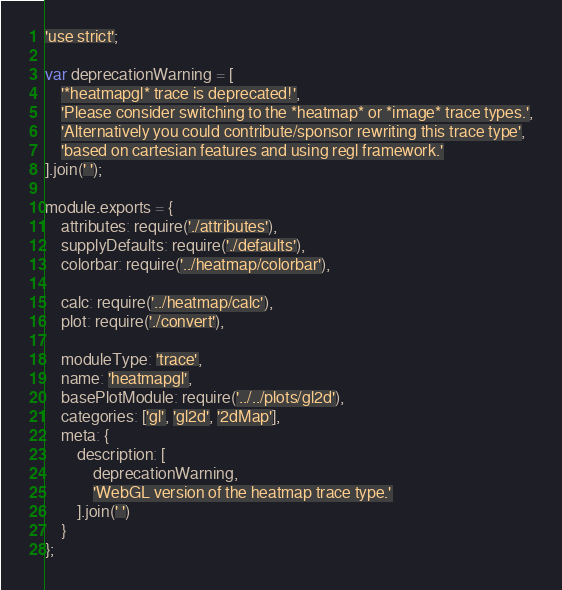Convert code to text. <code><loc_0><loc_0><loc_500><loc_500><_JavaScript_>'use strict';

var deprecationWarning = [
    '*heatmapgl* trace is deprecated!',
    'Please consider switching to the *heatmap* or *image* trace types.',
    'Alternatively you could contribute/sponsor rewriting this trace type',
    'based on cartesian features and using regl framework.'
].join(' ');

module.exports = {
    attributes: require('./attributes'),
    supplyDefaults: require('./defaults'),
    colorbar: require('../heatmap/colorbar'),

    calc: require('../heatmap/calc'),
    plot: require('./convert'),

    moduleType: 'trace',
    name: 'heatmapgl',
    basePlotModule: require('../../plots/gl2d'),
    categories: ['gl', 'gl2d', '2dMap'],
    meta: {
        description: [
            deprecationWarning,
            'WebGL version of the heatmap trace type.'
        ].join(' ')
    }
};
</code> 